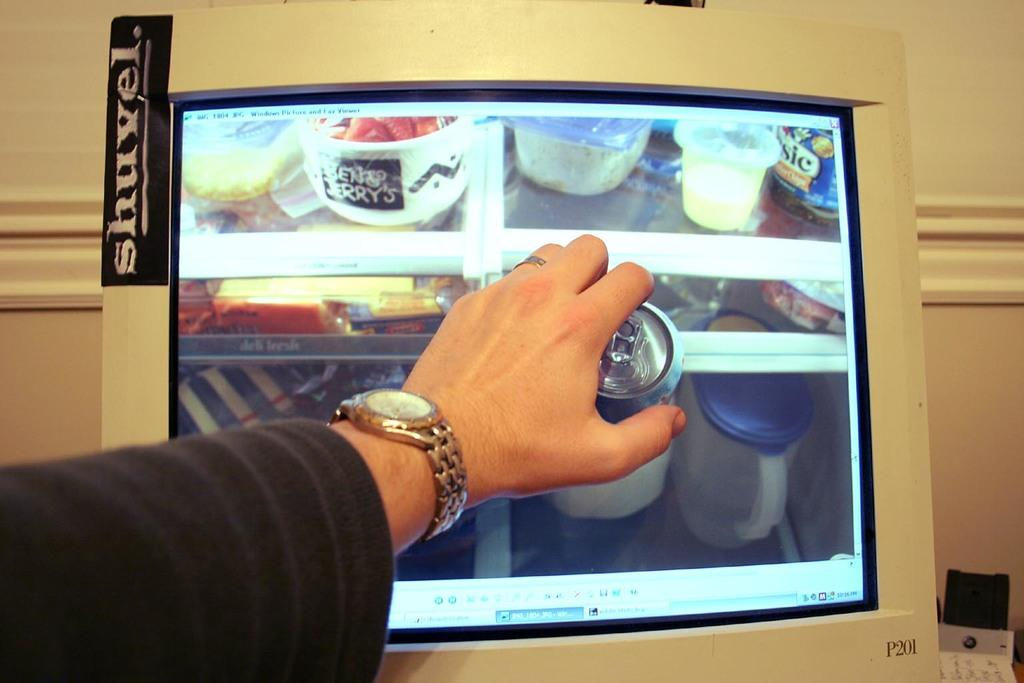<image>
Share a concise interpretation of the image provided. Persons hand holding a soda can to a computer screen with different food and drink items from Shuvel. 